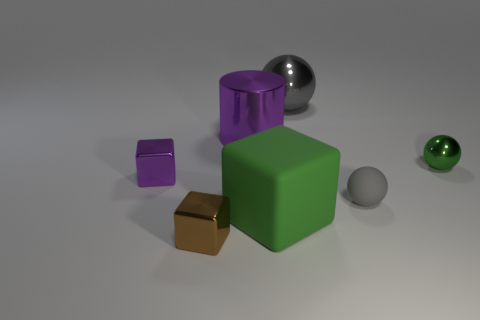Subtract all gray blocks. Subtract all cyan balls. How many blocks are left? 3 Add 3 small red matte balls. How many objects exist? 10 Subtract all balls. How many objects are left? 4 Subtract all big cubes. Subtract all large gray objects. How many objects are left? 5 Add 3 gray matte things. How many gray matte things are left? 4 Add 1 small cyan metal spheres. How many small cyan metal spheres exist? 1 Subtract 1 green cubes. How many objects are left? 6 